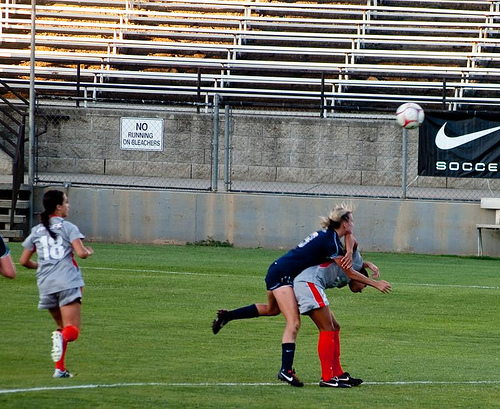<image>
Is the woman on the woman? Yes. Looking at the image, I can see the woman is positioned on top of the woman, with the woman providing support. 